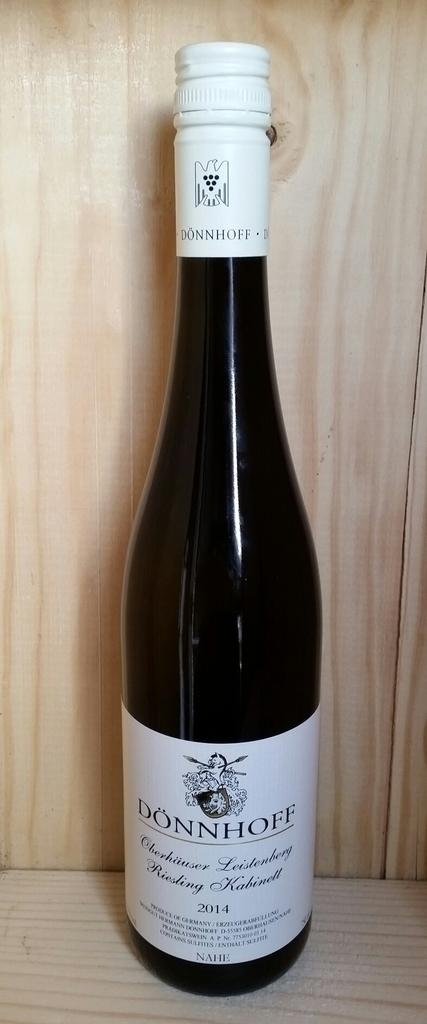<image>
Write a terse but informative summary of the picture. Black bottle with a white label that says "Donnhoff" on it. 